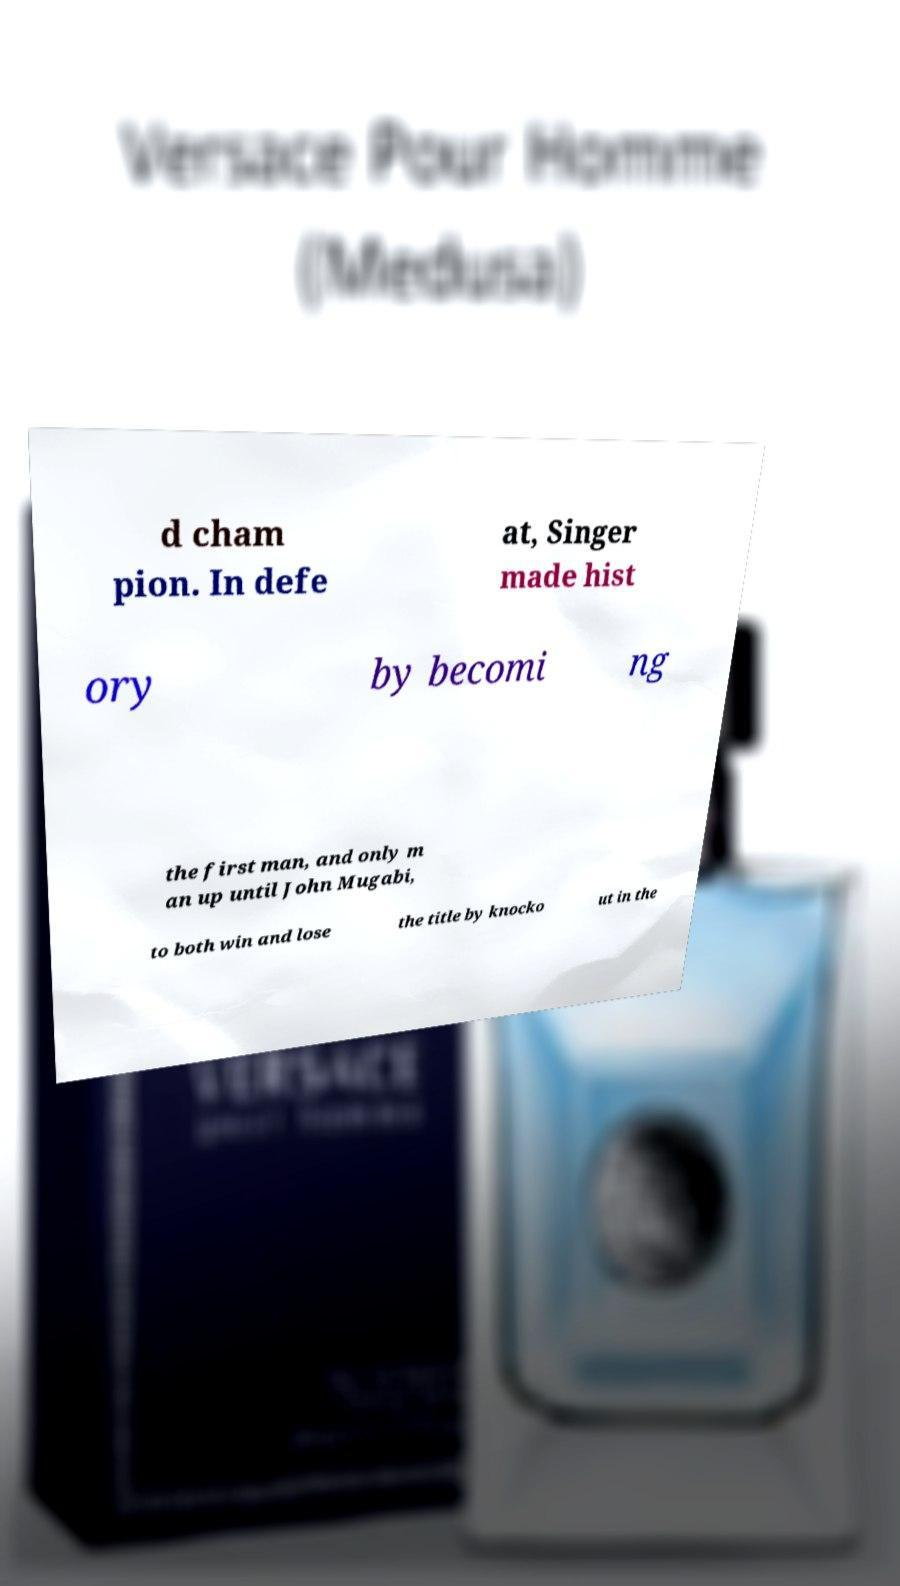Can you read and provide the text displayed in the image?This photo seems to have some interesting text. Can you extract and type it out for me? d cham pion. In defe at, Singer made hist ory by becomi ng the first man, and only m an up until John Mugabi, to both win and lose the title by knocko ut in the 